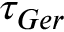Convert formula to latex. <formula><loc_0><loc_0><loc_500><loc_500>\tau _ { G e r }</formula> 